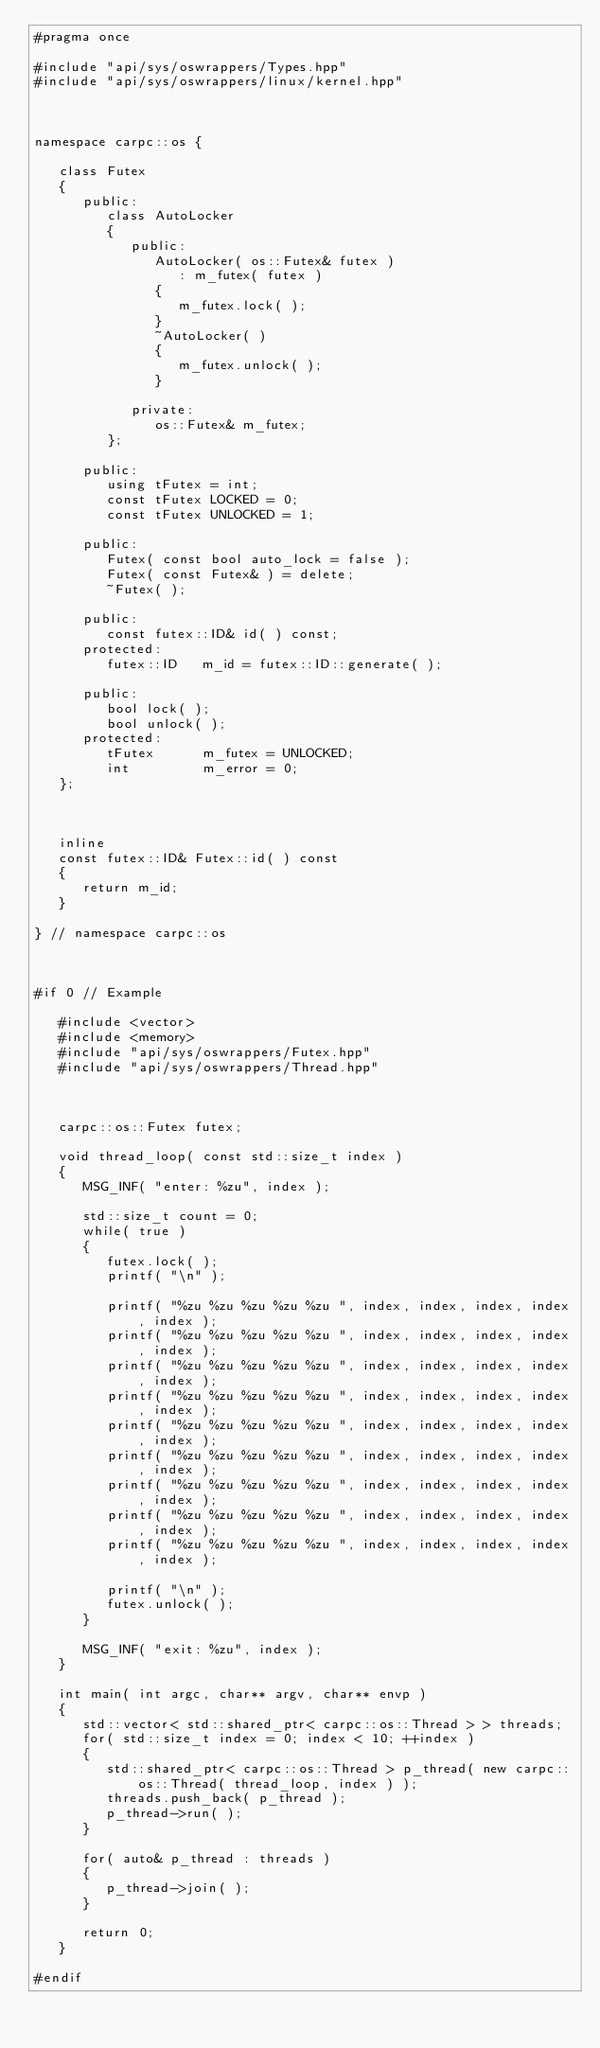<code> <loc_0><loc_0><loc_500><loc_500><_C++_>#pragma once

#include "api/sys/oswrappers/Types.hpp"
#include "api/sys/oswrappers/linux/kernel.hpp"



namespace carpc::os {

   class Futex
   {
      public:
         class AutoLocker
         {
            public:
               AutoLocker( os::Futex& futex )
                  : m_futex( futex )
               {
                  m_futex.lock( );
               }
               ~AutoLocker( )
               {
                  m_futex.unlock( );
               }

            private:
               os::Futex& m_futex;
         };

      public:
         using tFutex = int;
         const tFutex LOCKED = 0;
         const tFutex UNLOCKED = 1;

      public:
         Futex( const bool auto_lock = false );
         Futex( const Futex& ) = delete;
         ~Futex( );

      public:
         const futex::ID& id( ) const;
      protected:
         futex::ID   m_id = futex::ID::generate( );

      public:
         bool lock( );
         bool unlock( );
      protected:
         tFutex      m_futex = UNLOCKED;
         int         m_error = 0;
   };



   inline
   const futex::ID& Futex::id( ) const
   {
      return m_id;
   }

} // namespace carpc::os



#if 0 // Example

   #include <vector>
   #include <memory>
   #include "api/sys/oswrappers/Futex.hpp"
   #include "api/sys/oswrappers/Thread.hpp"



   carpc::os::Futex futex;

   void thread_loop( const std::size_t index )
   {
      MSG_INF( "enter: %zu", index );

      std::size_t count = 0;
      while( true )
      {
         futex.lock( );
         printf( "\n" );

         printf( "%zu %zu %zu %zu %zu ", index, index, index, index, index );
         printf( "%zu %zu %zu %zu %zu ", index, index, index, index, index );
         printf( "%zu %zu %zu %zu %zu ", index, index, index, index, index );
         printf( "%zu %zu %zu %zu %zu ", index, index, index, index, index );
         printf( "%zu %zu %zu %zu %zu ", index, index, index, index, index );
         printf( "%zu %zu %zu %zu %zu ", index, index, index, index, index );
         printf( "%zu %zu %zu %zu %zu ", index, index, index, index, index );
         printf( "%zu %zu %zu %zu %zu ", index, index, index, index, index );
         printf( "%zu %zu %zu %zu %zu ", index, index, index, index, index );

         printf( "\n" );
         futex.unlock( );
      }

      MSG_INF( "exit: %zu", index );
   }

   int main( int argc, char** argv, char** envp )
   {
      std::vector< std::shared_ptr< carpc::os::Thread > > threads;
      for( std::size_t index = 0; index < 10; ++index )
      {
         std::shared_ptr< carpc::os::Thread > p_thread( new carpc::os::Thread( thread_loop, index ) );
         threads.push_back( p_thread );
         p_thread->run( );
      }

      for( auto& p_thread : threads )
      {
         p_thread->join( );
      }

      return 0;
   }

#endif</code> 